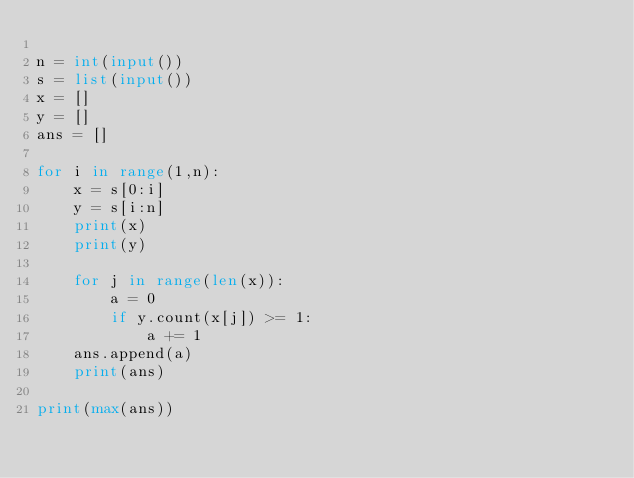Convert code to text. <code><loc_0><loc_0><loc_500><loc_500><_Python_>
n = int(input())
s = list(input())
x = []
y = []
ans = []

for i in range(1,n):
    x = s[0:i]
    y = s[i:n]
    print(x)
    print(y)

    for j in range(len(x)):
        a = 0
        if y.count(x[j]) >= 1:
            a += 1
    ans.append(a)
    print(ans)

print(max(ans))
</code> 